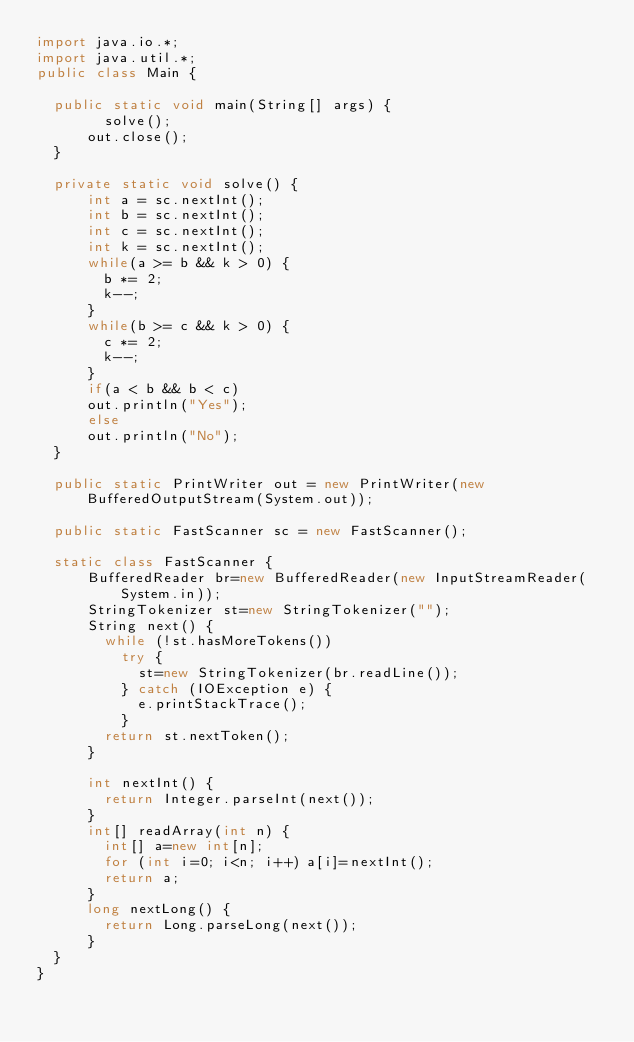Convert code to text. <code><loc_0><loc_0><loc_500><loc_500><_Java_>import java.io.*;
import java.util.*;
public class Main {
 
  public static void main(String[] args) { 
        solve();
      out.close();
  }

  private static void solve() {
      int a = sc.nextInt();
      int b = sc.nextInt();
      int c = sc.nextInt();
      int k = sc.nextInt();
      while(a >= b && k > 0) {
        b *= 2;
        k--;
      }
      while(b >= c && k > 0) {
        c *= 2;
        k--;
      }
      if(a < b && b < c)
      out.println("Yes");
      else
      out.println("No");
  }

  public static PrintWriter out = new PrintWriter(new BufferedOutputStream(System.out));
 
  public static FastScanner sc = new FastScanner();

  static class FastScanner {
      BufferedReader br=new BufferedReader(new InputStreamReader(System.in));
      StringTokenizer st=new StringTokenizer("");
      String next() {
        while (!st.hasMoreTokens())
          try {
            st=new StringTokenizer(br.readLine());
          } catch (IOException e) {
            e.printStackTrace();
          }
        return st.nextToken();
      }
      
      int nextInt() {
        return Integer.parseInt(next());
      }
      int[] readArray(int n) {
        int[] a=new int[n];
        for (int i=0; i<n; i++) a[i]=nextInt();
        return a;
      }
      long nextLong() {
        return Long.parseLong(next());
      }
  }
}</code> 